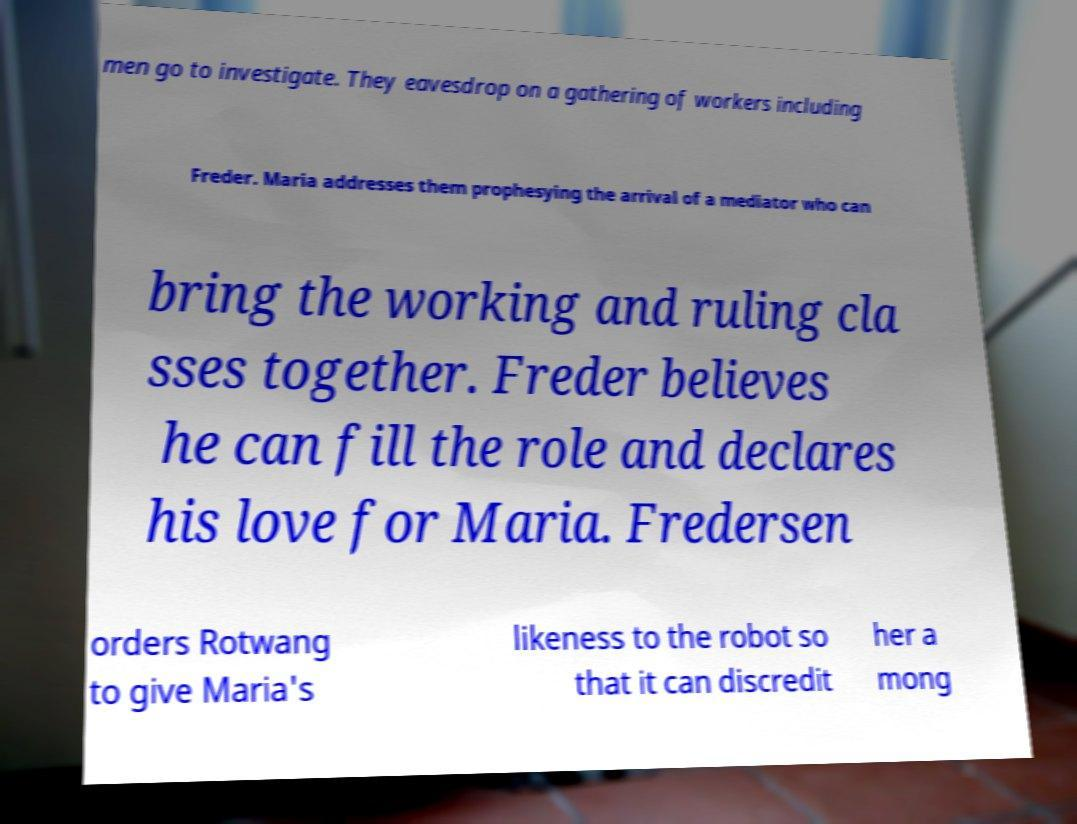I need the written content from this picture converted into text. Can you do that? men go to investigate. They eavesdrop on a gathering of workers including Freder. Maria addresses them prophesying the arrival of a mediator who can bring the working and ruling cla sses together. Freder believes he can fill the role and declares his love for Maria. Fredersen orders Rotwang to give Maria's likeness to the robot so that it can discredit her a mong 